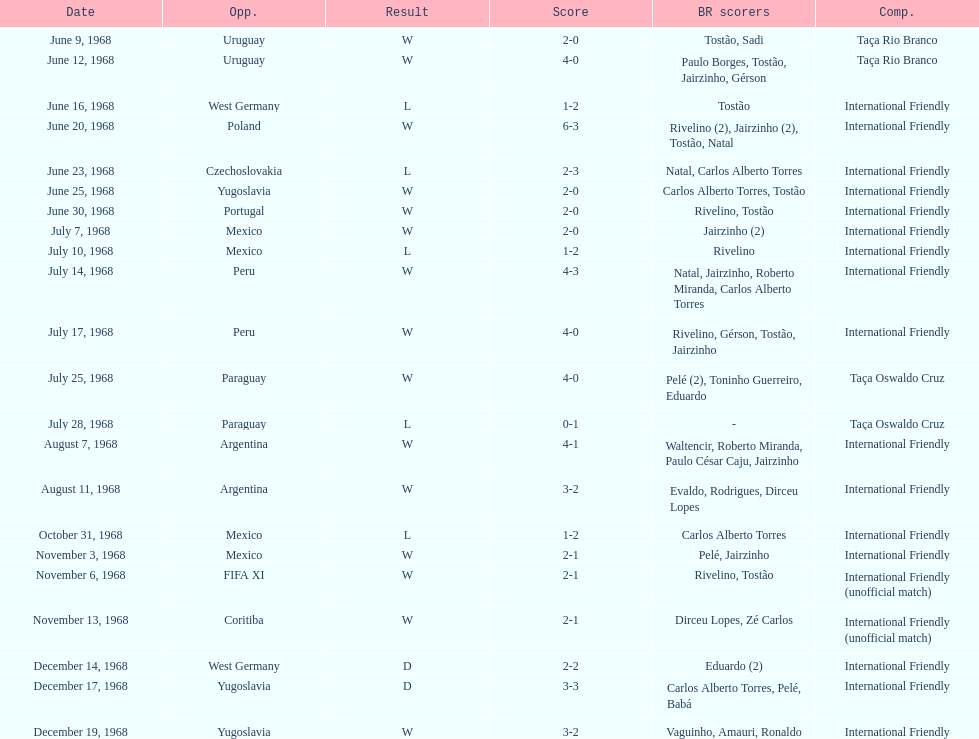What is the number of countries they have played? 11. 